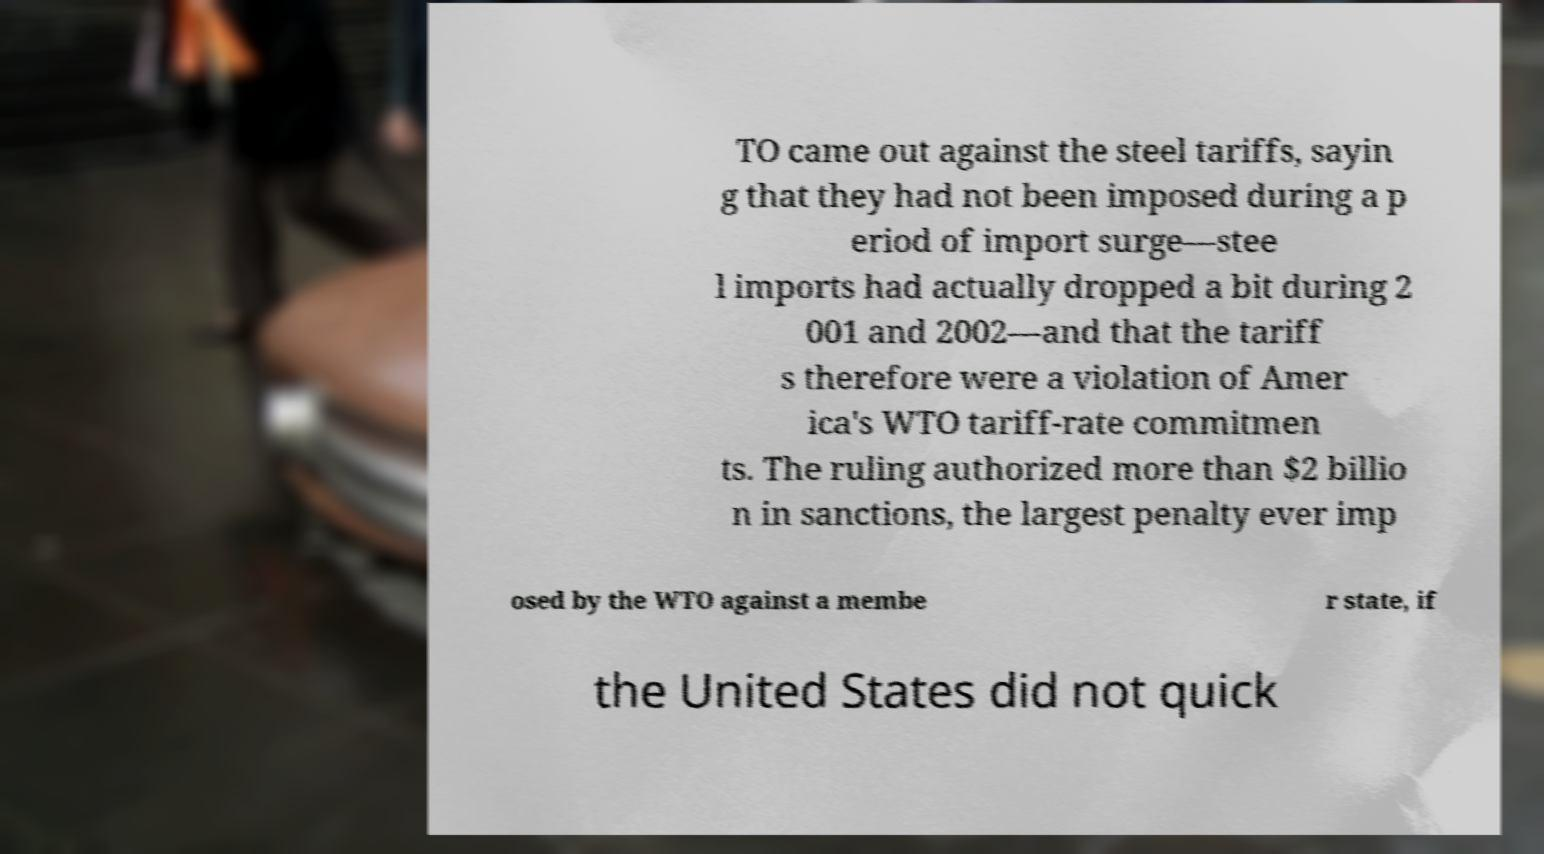What messages or text are displayed in this image? I need them in a readable, typed format. TO came out against the steel tariffs, sayin g that they had not been imposed during a p eriod of import surge—stee l imports had actually dropped a bit during 2 001 and 2002—and that the tariff s therefore were a violation of Amer ica's WTO tariff-rate commitmen ts. The ruling authorized more than $2 billio n in sanctions, the largest penalty ever imp osed by the WTO against a membe r state, if the United States did not quick 